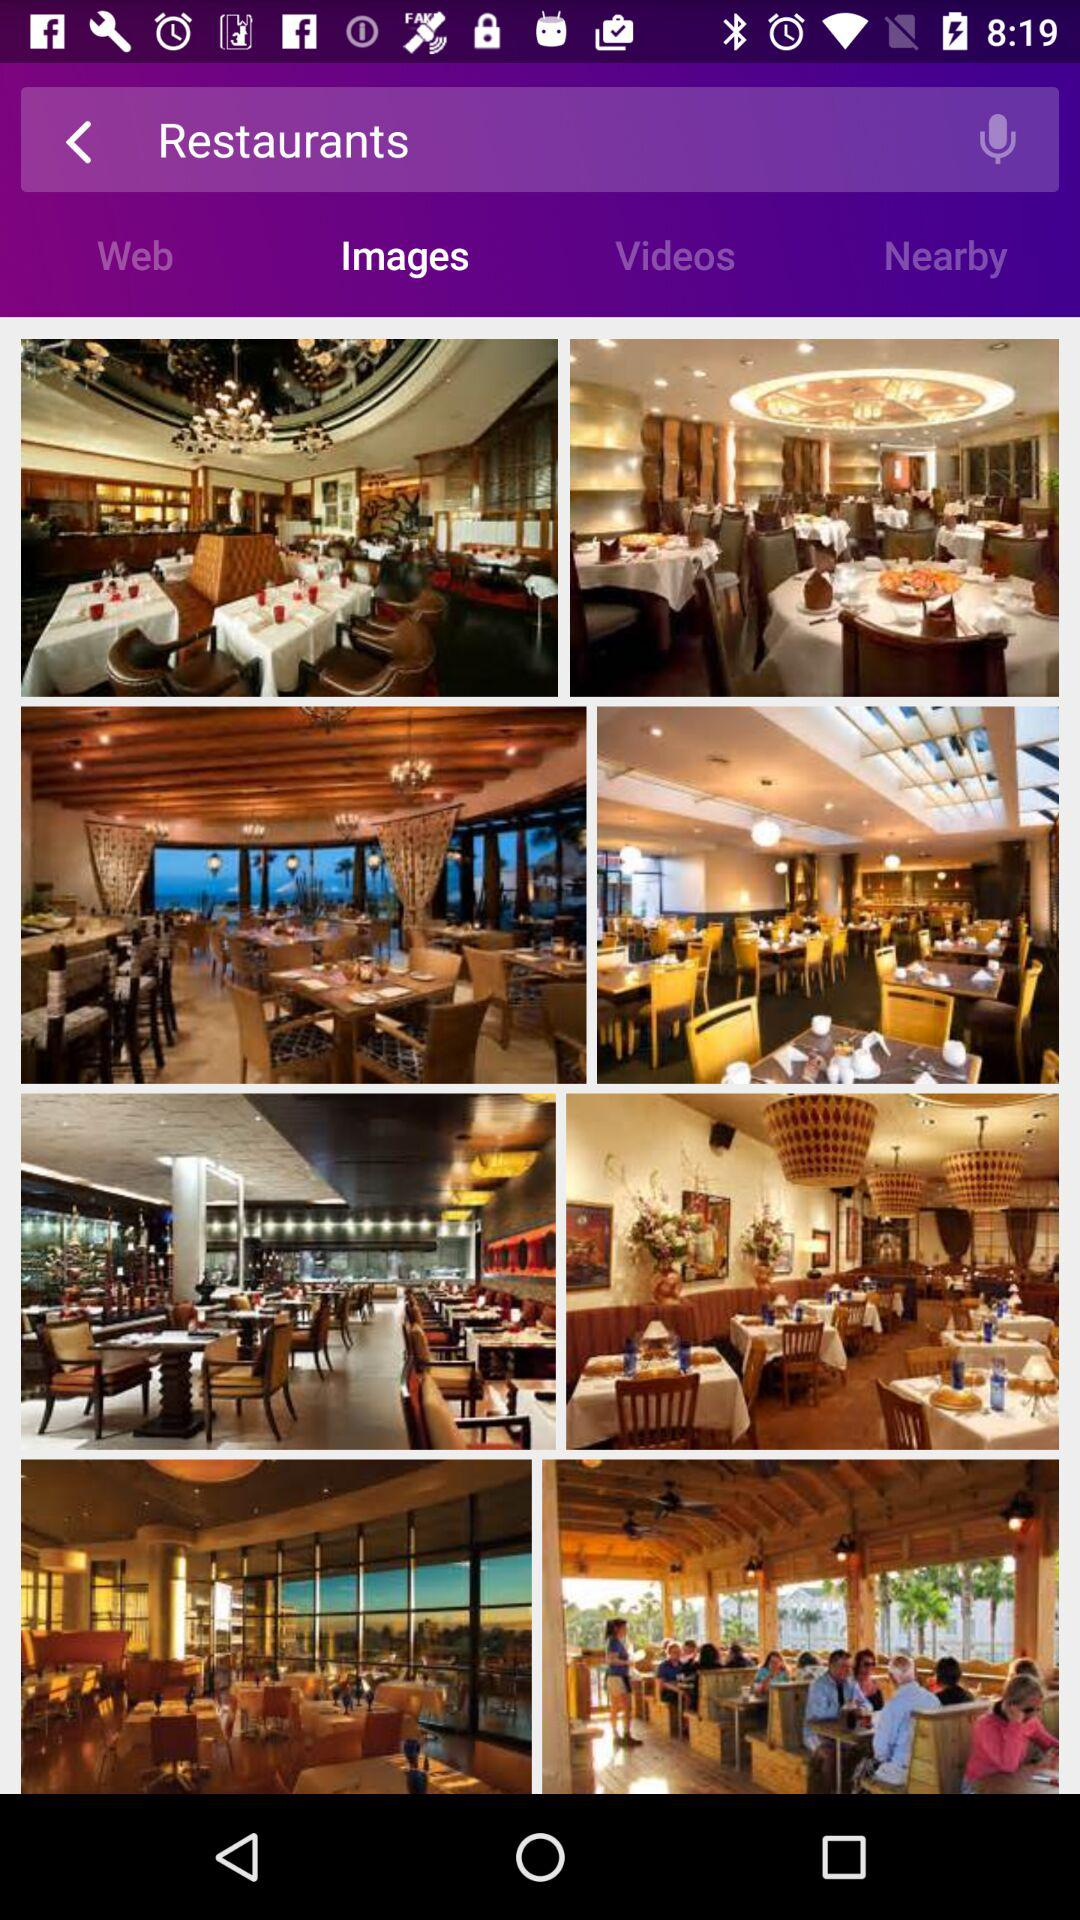Which tab is selected? The selected tab is "Images". 